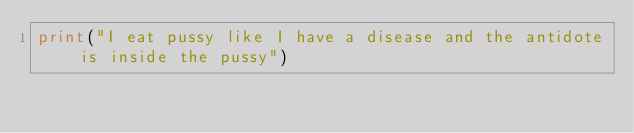Convert code to text. <code><loc_0><loc_0><loc_500><loc_500><_Python_>print("I eat pussy like I have a disease and the antidote is inside the pussy")</code> 